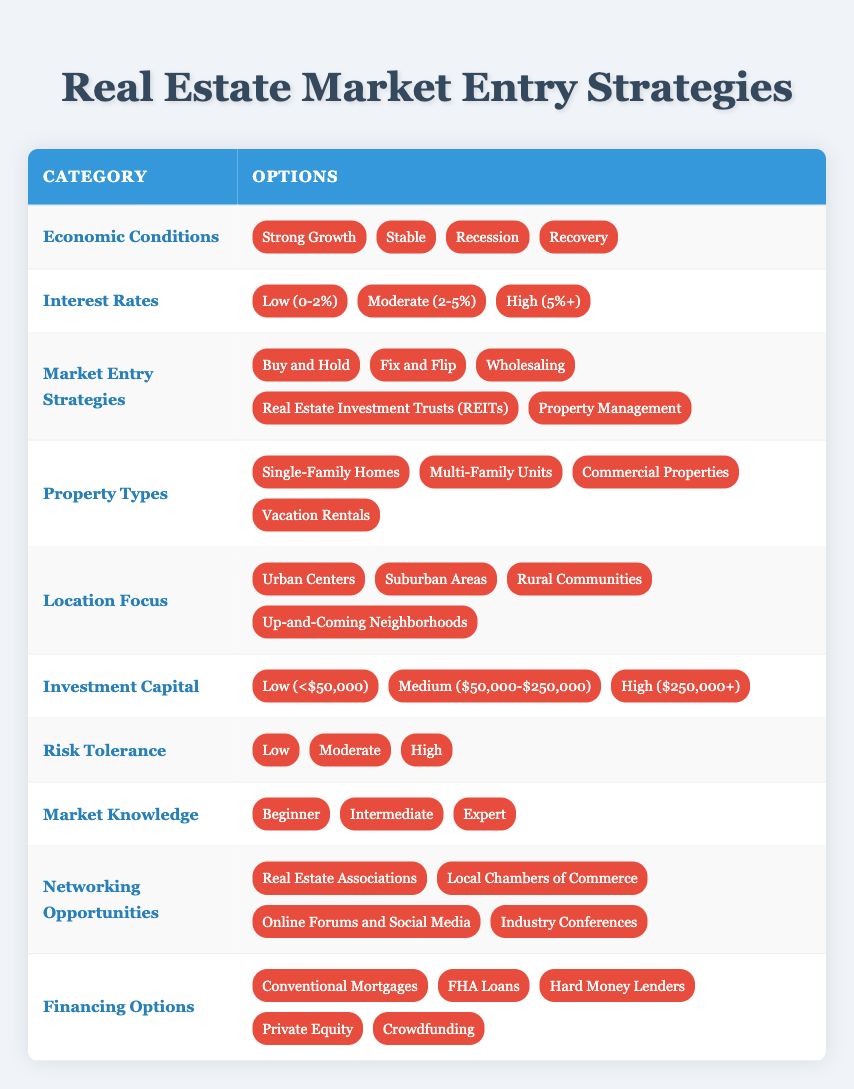What are the property types included in the table? The table lists four property types: Single-Family Homes, Multi-Family Units, Commercial Properties, and Vacation Rentals. These can be found in the "Property Types" category of the decision table.
Answer: Single-Family Homes, Multi-Family Units, Commercial Properties, Vacation Rentals Is "Buy and Hold" a market entry strategy listed for economic conditions in recovery? The table does not explicitly state whether "Buy and Hold" is recommended for recovery, but it is included among the market entry strategies which can be applied under various economic conditions. This means it is possible to consider it, but further context would be needed to confirm its appropriateness specifically for recovery.
Answer: Yes What is the highest level of investment capital mentioned? From the "Investment Capital" category, the table indicates three levels: Low (less than $50,000), Medium ($50,000 to $250,000), and High (more than $250,000). The "High" category represents the maximum level of capital that can be invested.
Answer: High (more than $250,000) How many strategies would be applicable in a strong growth economic situation with low interest rates? In a strong growth economy with low interest rates, all five market entry strategies would likely be applicable. This entails considering "Buy and Hold," "Fix and Flip," "Wholesaling," "Real Estate Investment Trusts (REITs)," and "Property Management." Therefore, it reveals that varied strategies could be utilized effectively during favorable economic conditions.
Answer: Five strategies Which location focuses are available under the table? The table categorizes four location focus areas: Urban Centers, Suburban Areas, Rural Communities, and Up-and-Coming Neighborhoods. These locations provide various options for real estate investments based on market conditions.
Answer: Urban Centers, Suburban Areas, Rural Communities, Up-and-Coming Neighborhoods Is it true that "Hard Money Lenders" are listed as a financing option? The financing options section of the table clearly includes "Hard Money Lenders" as one of the choices for securing funds in real estate investments. Therefore, the statement regarding its inclusion is accurate.
Answer: Yes What are the two risk tolerance levels indicated in the table? The risk tolerance section specifies three levels: Low, Moderate, and High. From these values, "Low" and "Moderate" can be selected as the first two levels. Although there is a third level, the question specifically requested just two.
Answer: Low, Moderate If a person has low investment capital and wishes to enter the market through property management, what does that imply regarding their ability to invest? Low investment capital implies that the person has less than $50,000 to invest. Property management typically requires additional financial capacity for operational and management costs. Thus, this may limit their ability to successfully invest in property management without additional financing or capital sources.
Answer: Limited ability to invest Which networking opportunity is associated with the highest engagement potential? Among the networking opportunities listed, "Industry Conferences" stand out as typically providing the highest engagement potential due to their nature of bringing together various stakeholders in the real estate sector, enabling robust interactions and networking possibilities.
Answer: Industry Conferences 